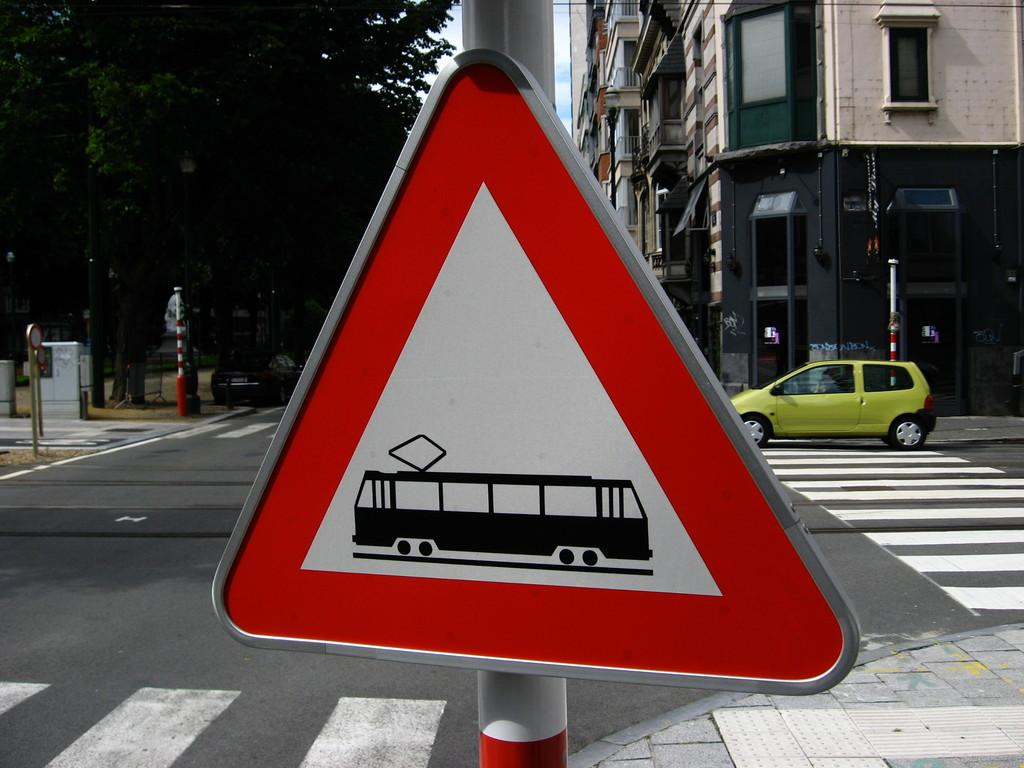What type of structures can be seen in the image? There are boards, poles, a road, vehicles, trees, and buildings in the image. Can you describe the road in the image? The road is visible in the image. What type of vehicles can be seen in the image? There are vehicles in the image. What type of natural elements are present in the image? Trees are present in the image. What type of scent can be detected in the image? There is no mention of a scent in the image, so it cannot be determined from the image. Is there a field visible in the image? There is no mention of a field in the image, so it cannot be determined from the image. 